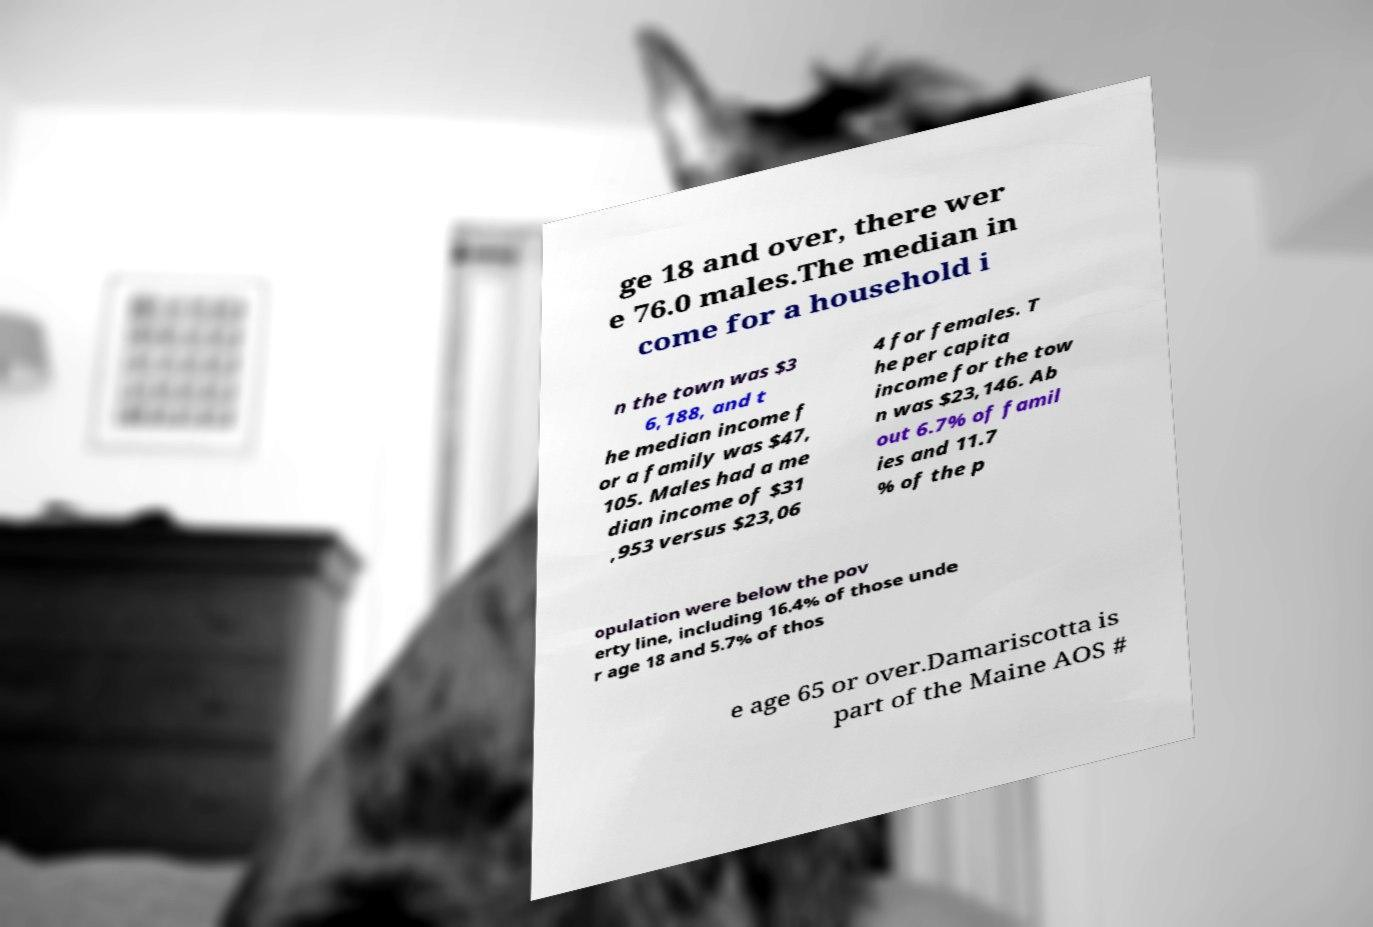Please read and relay the text visible in this image. What does it say? ge 18 and over, there wer e 76.0 males.The median in come for a household i n the town was $3 6,188, and t he median income f or a family was $47, 105. Males had a me dian income of $31 ,953 versus $23,06 4 for females. T he per capita income for the tow n was $23,146. Ab out 6.7% of famil ies and 11.7 % of the p opulation were below the pov erty line, including 16.4% of those unde r age 18 and 5.7% of thos e age 65 or over.Damariscotta is part of the Maine AOS # 